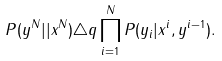Convert formula to latex. <formula><loc_0><loc_0><loc_500><loc_500>P ( y ^ { N } | | x ^ { N } ) \triangle q \prod _ { i = 1 } ^ { N } P ( y _ { i } | x ^ { i } , y ^ { i - 1 } ) .</formula> 